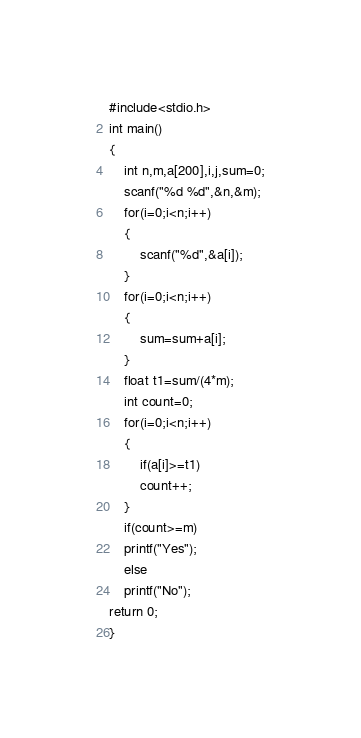Convert code to text. <code><loc_0><loc_0><loc_500><loc_500><_C_>#include<stdio.h>
int main()
{
	int n,m,a[200],i,j,sum=0;
	scanf("%d %d",&n,&m);
	for(i=0;i<n;i++)
	{
		scanf("%d",&a[i]);
	}
	for(i=0;i<n;i++)
	{
		sum=sum+a[i];
	}
	float t1=sum/(4*m);
	int count=0;
	for(i=0;i<n;i++)
	{
		if(a[i]>=t1)
		count++;
	}
	if(count>=m)
	printf("Yes");
	else
	printf("No");
return 0;
}</code> 